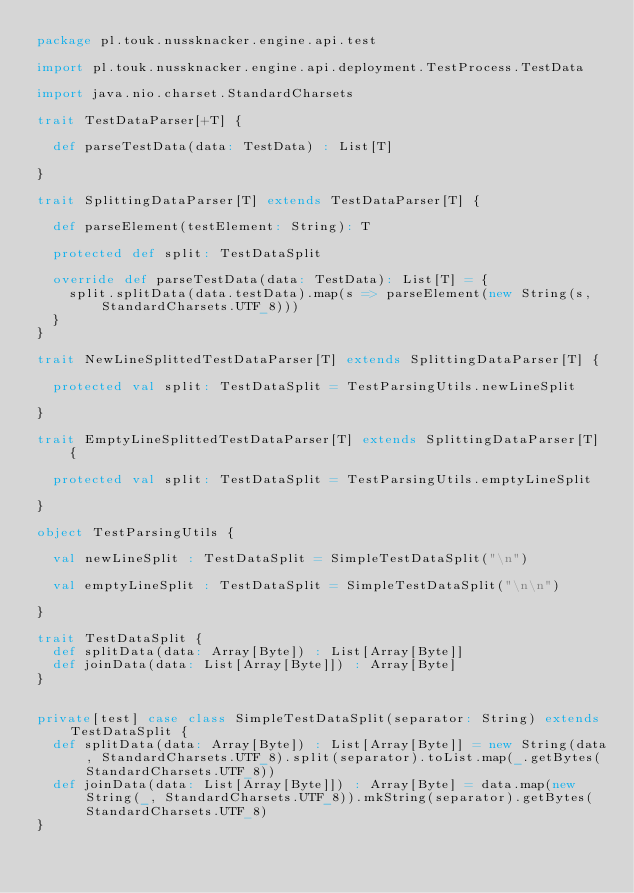<code> <loc_0><loc_0><loc_500><loc_500><_Scala_>package pl.touk.nussknacker.engine.api.test

import pl.touk.nussknacker.engine.api.deployment.TestProcess.TestData

import java.nio.charset.StandardCharsets

trait TestDataParser[+T] {

  def parseTestData(data: TestData) : List[T]

}

trait SplittingDataParser[T] extends TestDataParser[T] {

  def parseElement(testElement: String): T

  protected def split: TestDataSplit

  override def parseTestData(data: TestData): List[T] = {
    split.splitData(data.testData).map(s => parseElement(new String(s, StandardCharsets.UTF_8)))
  }
}

trait NewLineSplittedTestDataParser[T] extends SplittingDataParser[T] {

  protected val split: TestDataSplit = TestParsingUtils.newLineSplit

}

trait EmptyLineSplittedTestDataParser[T] extends SplittingDataParser[T] {

  protected val split: TestDataSplit = TestParsingUtils.emptyLineSplit

}

object TestParsingUtils {

  val newLineSplit : TestDataSplit = SimpleTestDataSplit("\n")

  val emptyLineSplit : TestDataSplit = SimpleTestDataSplit("\n\n")

}

trait TestDataSplit {
  def splitData(data: Array[Byte]) : List[Array[Byte]]
  def joinData(data: List[Array[Byte]]) : Array[Byte]
}


private[test] case class SimpleTestDataSplit(separator: String) extends TestDataSplit {
  def splitData(data: Array[Byte]) : List[Array[Byte]] = new String(data, StandardCharsets.UTF_8).split(separator).toList.map(_.getBytes(StandardCharsets.UTF_8))
  def joinData(data: List[Array[Byte]]) : Array[Byte] = data.map(new String(_, StandardCharsets.UTF_8)).mkString(separator).getBytes(StandardCharsets.UTF_8)
}
</code> 